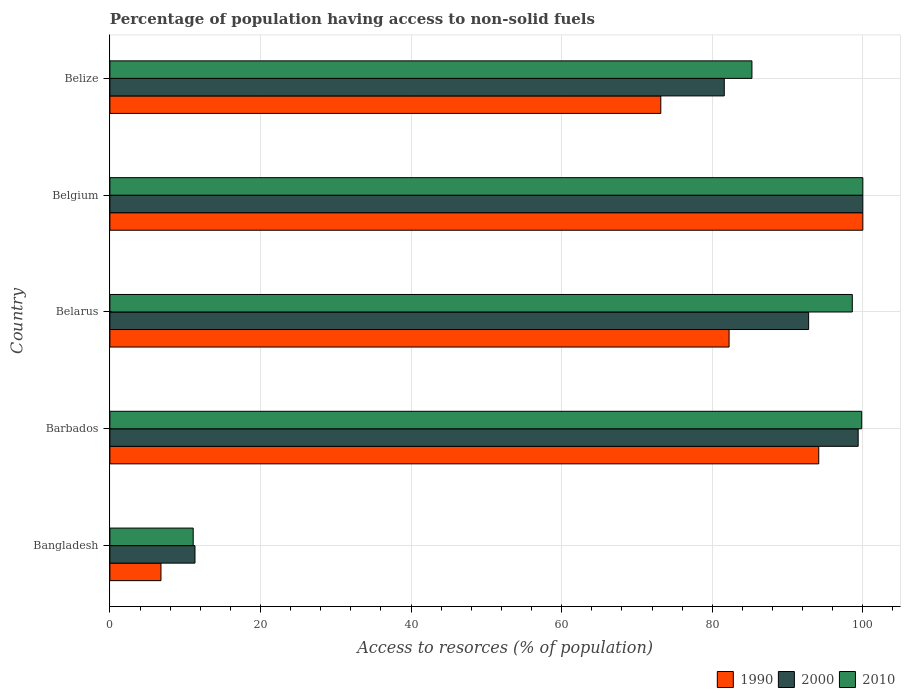How many groups of bars are there?
Give a very brief answer. 5. Are the number of bars on each tick of the Y-axis equal?
Give a very brief answer. Yes. What is the label of the 5th group of bars from the top?
Your response must be concise. Bangladesh. What is the percentage of population having access to non-solid fuels in 1990 in Barbados?
Your response must be concise. 94.14. Across all countries, what is the minimum percentage of population having access to non-solid fuels in 1990?
Your answer should be compact. 6.78. In which country was the percentage of population having access to non-solid fuels in 1990 maximum?
Offer a terse response. Belgium. In which country was the percentage of population having access to non-solid fuels in 2000 minimum?
Your answer should be compact. Bangladesh. What is the total percentage of population having access to non-solid fuels in 2010 in the graph?
Make the answer very short. 394.78. What is the difference between the percentage of population having access to non-solid fuels in 1990 in Belgium and that in Belize?
Offer a terse response. 26.83. What is the difference between the percentage of population having access to non-solid fuels in 1990 in Barbados and the percentage of population having access to non-solid fuels in 2010 in Belarus?
Offer a terse response. -4.46. What is the average percentage of population having access to non-solid fuels in 1990 per country?
Your answer should be very brief. 71.27. What is the difference between the percentage of population having access to non-solid fuels in 2010 and percentage of population having access to non-solid fuels in 1990 in Bangladesh?
Offer a very short reply. 4.28. What is the ratio of the percentage of population having access to non-solid fuels in 1990 in Belarus to that in Belize?
Make the answer very short. 1.12. Is the percentage of population having access to non-solid fuels in 2010 in Barbados less than that in Belize?
Offer a very short reply. No. What is the difference between the highest and the second highest percentage of population having access to non-solid fuels in 2000?
Offer a terse response. 0.62. What is the difference between the highest and the lowest percentage of population having access to non-solid fuels in 2000?
Provide a short and direct response. 88.7. In how many countries, is the percentage of population having access to non-solid fuels in 2010 greater than the average percentage of population having access to non-solid fuels in 2010 taken over all countries?
Give a very brief answer. 4. What does the 3rd bar from the top in Bangladesh represents?
Ensure brevity in your answer.  1990. What does the 1st bar from the bottom in Bangladesh represents?
Your answer should be very brief. 1990. How many bars are there?
Your response must be concise. 15. What is the difference between two consecutive major ticks on the X-axis?
Ensure brevity in your answer.  20. Where does the legend appear in the graph?
Offer a terse response. Bottom right. How are the legend labels stacked?
Your response must be concise. Horizontal. What is the title of the graph?
Offer a very short reply. Percentage of population having access to non-solid fuels. What is the label or title of the X-axis?
Your answer should be compact. Access to resorces (% of population). What is the Access to resorces (% of population) in 1990 in Bangladesh?
Offer a very short reply. 6.78. What is the Access to resorces (% of population) in 2000 in Bangladesh?
Ensure brevity in your answer.  11.3. What is the Access to resorces (% of population) in 2010 in Bangladesh?
Ensure brevity in your answer.  11.07. What is the Access to resorces (% of population) of 1990 in Barbados?
Your answer should be very brief. 94.14. What is the Access to resorces (% of population) of 2000 in Barbados?
Provide a succinct answer. 99.38. What is the Access to resorces (% of population) of 2010 in Barbados?
Your answer should be very brief. 99.85. What is the Access to resorces (% of population) of 1990 in Belarus?
Provide a succinct answer. 82.24. What is the Access to resorces (% of population) in 2000 in Belarus?
Give a very brief answer. 92.8. What is the Access to resorces (% of population) of 2010 in Belarus?
Your answer should be very brief. 98.6. What is the Access to resorces (% of population) of 2010 in Belgium?
Provide a succinct answer. 100. What is the Access to resorces (% of population) in 1990 in Belize?
Keep it short and to the point. 73.17. What is the Access to resorces (% of population) in 2000 in Belize?
Ensure brevity in your answer.  81.6. What is the Access to resorces (% of population) of 2010 in Belize?
Offer a very short reply. 85.27. Across all countries, what is the maximum Access to resorces (% of population) of 1990?
Offer a very short reply. 100. Across all countries, what is the maximum Access to resorces (% of population) of 2000?
Your response must be concise. 100. Across all countries, what is the maximum Access to resorces (% of population) in 2010?
Keep it short and to the point. 100. Across all countries, what is the minimum Access to resorces (% of population) in 1990?
Provide a short and direct response. 6.78. Across all countries, what is the minimum Access to resorces (% of population) in 2000?
Your response must be concise. 11.3. Across all countries, what is the minimum Access to resorces (% of population) of 2010?
Give a very brief answer. 11.07. What is the total Access to resorces (% of population) of 1990 in the graph?
Your answer should be very brief. 356.33. What is the total Access to resorces (% of population) of 2000 in the graph?
Your answer should be compact. 385.08. What is the total Access to resorces (% of population) in 2010 in the graph?
Give a very brief answer. 394.78. What is the difference between the Access to resorces (% of population) of 1990 in Bangladesh and that in Barbados?
Provide a short and direct response. -87.36. What is the difference between the Access to resorces (% of population) in 2000 in Bangladesh and that in Barbados?
Provide a succinct answer. -88.08. What is the difference between the Access to resorces (% of population) in 2010 in Bangladesh and that in Barbados?
Give a very brief answer. -88.78. What is the difference between the Access to resorces (% of population) in 1990 in Bangladesh and that in Belarus?
Keep it short and to the point. -75.45. What is the difference between the Access to resorces (% of population) in 2000 in Bangladesh and that in Belarus?
Give a very brief answer. -81.5. What is the difference between the Access to resorces (% of population) of 2010 in Bangladesh and that in Belarus?
Ensure brevity in your answer.  -87.53. What is the difference between the Access to resorces (% of population) in 1990 in Bangladesh and that in Belgium?
Ensure brevity in your answer.  -93.22. What is the difference between the Access to resorces (% of population) of 2000 in Bangladesh and that in Belgium?
Provide a succinct answer. -88.7. What is the difference between the Access to resorces (% of population) in 2010 in Bangladesh and that in Belgium?
Your response must be concise. -88.93. What is the difference between the Access to resorces (% of population) in 1990 in Bangladesh and that in Belize?
Your answer should be very brief. -66.38. What is the difference between the Access to resorces (% of population) of 2000 in Bangladesh and that in Belize?
Your response must be concise. -70.29. What is the difference between the Access to resorces (% of population) in 2010 in Bangladesh and that in Belize?
Provide a succinct answer. -74.21. What is the difference between the Access to resorces (% of population) of 1990 in Barbados and that in Belarus?
Make the answer very short. 11.91. What is the difference between the Access to resorces (% of population) of 2000 in Barbados and that in Belarus?
Your answer should be very brief. 6.58. What is the difference between the Access to resorces (% of population) in 2010 in Barbados and that in Belarus?
Your answer should be compact. 1.25. What is the difference between the Access to resorces (% of population) of 1990 in Barbados and that in Belgium?
Your answer should be very brief. -5.86. What is the difference between the Access to resorces (% of population) of 2000 in Barbados and that in Belgium?
Provide a short and direct response. -0.62. What is the difference between the Access to resorces (% of population) in 2010 in Barbados and that in Belgium?
Offer a very short reply. -0.15. What is the difference between the Access to resorces (% of population) of 1990 in Barbados and that in Belize?
Ensure brevity in your answer.  20.98. What is the difference between the Access to resorces (% of population) of 2000 in Barbados and that in Belize?
Your answer should be very brief. 17.78. What is the difference between the Access to resorces (% of population) in 2010 in Barbados and that in Belize?
Provide a short and direct response. 14.58. What is the difference between the Access to resorces (% of population) in 1990 in Belarus and that in Belgium?
Your response must be concise. -17.76. What is the difference between the Access to resorces (% of population) of 2000 in Belarus and that in Belgium?
Make the answer very short. -7.2. What is the difference between the Access to resorces (% of population) in 2010 in Belarus and that in Belgium?
Keep it short and to the point. -1.4. What is the difference between the Access to resorces (% of population) of 1990 in Belarus and that in Belize?
Your answer should be compact. 9.07. What is the difference between the Access to resorces (% of population) in 2000 in Belarus and that in Belize?
Offer a very short reply. 11.2. What is the difference between the Access to resorces (% of population) of 2010 in Belarus and that in Belize?
Your answer should be very brief. 13.33. What is the difference between the Access to resorces (% of population) in 1990 in Belgium and that in Belize?
Your answer should be very brief. 26.83. What is the difference between the Access to resorces (% of population) of 2000 in Belgium and that in Belize?
Your answer should be very brief. 18.4. What is the difference between the Access to resorces (% of population) in 2010 in Belgium and that in Belize?
Your answer should be very brief. 14.73. What is the difference between the Access to resorces (% of population) in 1990 in Bangladesh and the Access to resorces (% of population) in 2000 in Barbados?
Offer a terse response. -92.6. What is the difference between the Access to resorces (% of population) in 1990 in Bangladesh and the Access to resorces (% of population) in 2010 in Barbados?
Offer a very short reply. -93.06. What is the difference between the Access to resorces (% of population) in 2000 in Bangladesh and the Access to resorces (% of population) in 2010 in Barbados?
Your answer should be very brief. -88.55. What is the difference between the Access to resorces (% of population) of 1990 in Bangladesh and the Access to resorces (% of population) of 2000 in Belarus?
Ensure brevity in your answer.  -86.02. What is the difference between the Access to resorces (% of population) of 1990 in Bangladesh and the Access to resorces (% of population) of 2010 in Belarus?
Ensure brevity in your answer.  -91.82. What is the difference between the Access to resorces (% of population) in 2000 in Bangladesh and the Access to resorces (% of population) in 2010 in Belarus?
Give a very brief answer. -87.3. What is the difference between the Access to resorces (% of population) in 1990 in Bangladesh and the Access to resorces (% of population) in 2000 in Belgium?
Make the answer very short. -93.22. What is the difference between the Access to resorces (% of population) in 1990 in Bangladesh and the Access to resorces (% of population) in 2010 in Belgium?
Your answer should be very brief. -93.22. What is the difference between the Access to resorces (% of population) of 2000 in Bangladesh and the Access to resorces (% of population) of 2010 in Belgium?
Provide a succinct answer. -88.7. What is the difference between the Access to resorces (% of population) of 1990 in Bangladesh and the Access to resorces (% of population) of 2000 in Belize?
Ensure brevity in your answer.  -74.81. What is the difference between the Access to resorces (% of population) of 1990 in Bangladesh and the Access to resorces (% of population) of 2010 in Belize?
Keep it short and to the point. -78.49. What is the difference between the Access to resorces (% of population) in 2000 in Bangladesh and the Access to resorces (% of population) in 2010 in Belize?
Keep it short and to the point. -73.97. What is the difference between the Access to resorces (% of population) in 1990 in Barbados and the Access to resorces (% of population) in 2000 in Belarus?
Your response must be concise. 1.34. What is the difference between the Access to resorces (% of population) of 1990 in Barbados and the Access to resorces (% of population) of 2010 in Belarus?
Make the answer very short. -4.46. What is the difference between the Access to resorces (% of population) in 2000 in Barbados and the Access to resorces (% of population) in 2010 in Belarus?
Keep it short and to the point. 0.78. What is the difference between the Access to resorces (% of population) of 1990 in Barbados and the Access to resorces (% of population) of 2000 in Belgium?
Offer a very short reply. -5.86. What is the difference between the Access to resorces (% of population) in 1990 in Barbados and the Access to resorces (% of population) in 2010 in Belgium?
Offer a terse response. -5.86. What is the difference between the Access to resorces (% of population) in 2000 in Barbados and the Access to resorces (% of population) in 2010 in Belgium?
Your answer should be compact. -0.62. What is the difference between the Access to resorces (% of population) in 1990 in Barbados and the Access to resorces (% of population) in 2000 in Belize?
Your answer should be compact. 12.55. What is the difference between the Access to resorces (% of population) of 1990 in Barbados and the Access to resorces (% of population) of 2010 in Belize?
Give a very brief answer. 8.87. What is the difference between the Access to resorces (% of population) of 2000 in Barbados and the Access to resorces (% of population) of 2010 in Belize?
Your answer should be compact. 14.11. What is the difference between the Access to resorces (% of population) of 1990 in Belarus and the Access to resorces (% of population) of 2000 in Belgium?
Give a very brief answer. -17.76. What is the difference between the Access to resorces (% of population) in 1990 in Belarus and the Access to resorces (% of population) in 2010 in Belgium?
Make the answer very short. -17.76. What is the difference between the Access to resorces (% of population) in 2000 in Belarus and the Access to resorces (% of population) in 2010 in Belgium?
Provide a short and direct response. -7.2. What is the difference between the Access to resorces (% of population) of 1990 in Belarus and the Access to resorces (% of population) of 2000 in Belize?
Your answer should be compact. 0.64. What is the difference between the Access to resorces (% of population) in 1990 in Belarus and the Access to resorces (% of population) in 2010 in Belize?
Your answer should be compact. -3.03. What is the difference between the Access to resorces (% of population) of 2000 in Belarus and the Access to resorces (% of population) of 2010 in Belize?
Make the answer very short. 7.53. What is the difference between the Access to resorces (% of population) of 1990 in Belgium and the Access to resorces (% of population) of 2000 in Belize?
Offer a terse response. 18.4. What is the difference between the Access to resorces (% of population) in 1990 in Belgium and the Access to resorces (% of population) in 2010 in Belize?
Your response must be concise. 14.73. What is the difference between the Access to resorces (% of population) of 2000 in Belgium and the Access to resorces (% of population) of 2010 in Belize?
Make the answer very short. 14.73. What is the average Access to resorces (% of population) in 1990 per country?
Your answer should be compact. 71.27. What is the average Access to resorces (% of population) of 2000 per country?
Your answer should be very brief. 77.02. What is the average Access to resorces (% of population) in 2010 per country?
Make the answer very short. 78.96. What is the difference between the Access to resorces (% of population) of 1990 and Access to resorces (% of population) of 2000 in Bangladesh?
Your answer should be very brief. -4.52. What is the difference between the Access to resorces (% of population) of 1990 and Access to resorces (% of population) of 2010 in Bangladesh?
Keep it short and to the point. -4.28. What is the difference between the Access to resorces (% of population) in 2000 and Access to resorces (% of population) in 2010 in Bangladesh?
Provide a short and direct response. 0.24. What is the difference between the Access to resorces (% of population) of 1990 and Access to resorces (% of population) of 2000 in Barbados?
Your answer should be compact. -5.23. What is the difference between the Access to resorces (% of population) of 1990 and Access to resorces (% of population) of 2010 in Barbados?
Ensure brevity in your answer.  -5.7. What is the difference between the Access to resorces (% of population) of 2000 and Access to resorces (% of population) of 2010 in Barbados?
Provide a short and direct response. -0.47. What is the difference between the Access to resorces (% of population) of 1990 and Access to resorces (% of population) of 2000 in Belarus?
Your answer should be very brief. -10.56. What is the difference between the Access to resorces (% of population) in 1990 and Access to resorces (% of population) in 2010 in Belarus?
Your response must be concise. -16.36. What is the difference between the Access to resorces (% of population) of 2000 and Access to resorces (% of population) of 2010 in Belarus?
Provide a short and direct response. -5.8. What is the difference between the Access to resorces (% of population) of 1990 and Access to resorces (% of population) of 2000 in Belize?
Give a very brief answer. -8.43. What is the difference between the Access to resorces (% of population) of 1990 and Access to resorces (% of population) of 2010 in Belize?
Your answer should be very brief. -12.1. What is the difference between the Access to resorces (% of population) of 2000 and Access to resorces (% of population) of 2010 in Belize?
Offer a terse response. -3.67. What is the ratio of the Access to resorces (% of population) in 1990 in Bangladesh to that in Barbados?
Your answer should be compact. 0.07. What is the ratio of the Access to resorces (% of population) in 2000 in Bangladesh to that in Barbados?
Your answer should be compact. 0.11. What is the ratio of the Access to resorces (% of population) in 2010 in Bangladesh to that in Barbados?
Provide a short and direct response. 0.11. What is the ratio of the Access to resorces (% of population) in 1990 in Bangladesh to that in Belarus?
Your response must be concise. 0.08. What is the ratio of the Access to resorces (% of population) of 2000 in Bangladesh to that in Belarus?
Provide a short and direct response. 0.12. What is the ratio of the Access to resorces (% of population) of 2010 in Bangladesh to that in Belarus?
Keep it short and to the point. 0.11. What is the ratio of the Access to resorces (% of population) of 1990 in Bangladesh to that in Belgium?
Keep it short and to the point. 0.07. What is the ratio of the Access to resorces (% of population) of 2000 in Bangladesh to that in Belgium?
Your answer should be compact. 0.11. What is the ratio of the Access to resorces (% of population) of 2010 in Bangladesh to that in Belgium?
Provide a succinct answer. 0.11. What is the ratio of the Access to resorces (% of population) of 1990 in Bangladesh to that in Belize?
Provide a succinct answer. 0.09. What is the ratio of the Access to resorces (% of population) of 2000 in Bangladesh to that in Belize?
Make the answer very short. 0.14. What is the ratio of the Access to resorces (% of population) in 2010 in Bangladesh to that in Belize?
Your answer should be compact. 0.13. What is the ratio of the Access to resorces (% of population) in 1990 in Barbados to that in Belarus?
Ensure brevity in your answer.  1.14. What is the ratio of the Access to resorces (% of population) in 2000 in Barbados to that in Belarus?
Give a very brief answer. 1.07. What is the ratio of the Access to resorces (% of population) in 2010 in Barbados to that in Belarus?
Keep it short and to the point. 1.01. What is the ratio of the Access to resorces (% of population) of 1990 in Barbados to that in Belgium?
Offer a very short reply. 0.94. What is the ratio of the Access to resorces (% of population) in 2000 in Barbados to that in Belgium?
Offer a terse response. 0.99. What is the ratio of the Access to resorces (% of population) of 2010 in Barbados to that in Belgium?
Give a very brief answer. 1. What is the ratio of the Access to resorces (% of population) of 1990 in Barbados to that in Belize?
Your answer should be very brief. 1.29. What is the ratio of the Access to resorces (% of population) of 2000 in Barbados to that in Belize?
Offer a terse response. 1.22. What is the ratio of the Access to resorces (% of population) of 2010 in Barbados to that in Belize?
Provide a succinct answer. 1.17. What is the ratio of the Access to resorces (% of population) of 1990 in Belarus to that in Belgium?
Give a very brief answer. 0.82. What is the ratio of the Access to resorces (% of population) of 2000 in Belarus to that in Belgium?
Your response must be concise. 0.93. What is the ratio of the Access to resorces (% of population) of 1990 in Belarus to that in Belize?
Ensure brevity in your answer.  1.12. What is the ratio of the Access to resorces (% of population) in 2000 in Belarus to that in Belize?
Offer a terse response. 1.14. What is the ratio of the Access to resorces (% of population) of 2010 in Belarus to that in Belize?
Offer a terse response. 1.16. What is the ratio of the Access to resorces (% of population) in 1990 in Belgium to that in Belize?
Provide a short and direct response. 1.37. What is the ratio of the Access to resorces (% of population) of 2000 in Belgium to that in Belize?
Give a very brief answer. 1.23. What is the ratio of the Access to resorces (% of population) of 2010 in Belgium to that in Belize?
Give a very brief answer. 1.17. What is the difference between the highest and the second highest Access to resorces (% of population) in 1990?
Offer a terse response. 5.86. What is the difference between the highest and the second highest Access to resorces (% of population) in 2000?
Provide a succinct answer. 0.62. What is the difference between the highest and the second highest Access to resorces (% of population) of 2010?
Provide a short and direct response. 0.15. What is the difference between the highest and the lowest Access to resorces (% of population) of 1990?
Provide a succinct answer. 93.22. What is the difference between the highest and the lowest Access to resorces (% of population) in 2000?
Offer a terse response. 88.7. What is the difference between the highest and the lowest Access to resorces (% of population) in 2010?
Ensure brevity in your answer.  88.93. 